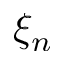<formula> <loc_0><loc_0><loc_500><loc_500>\xi _ { n }</formula> 